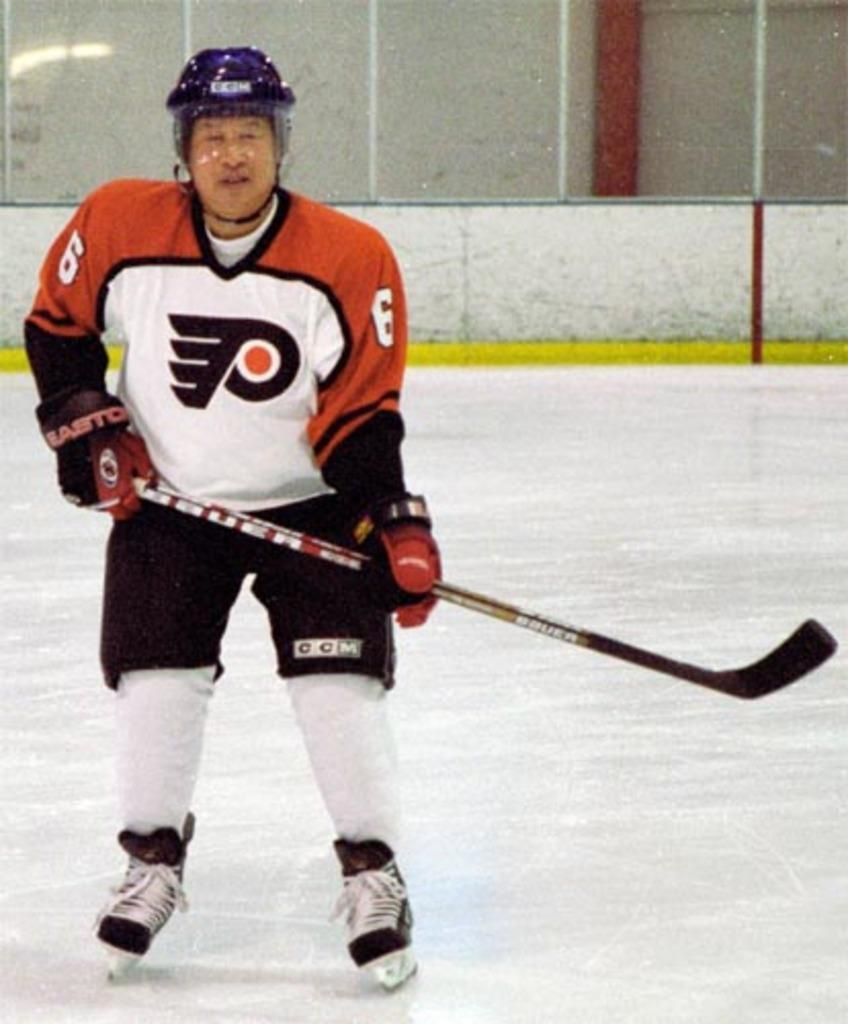Who or what is present in the image? There is a person in the image. What is the person wearing? The person is wearing a dress with white, orange, and black colors. What is the person holding in the image? The person is holding a hockey stick. What can be seen in the background of the image? There is a white-colored wall in the background of the image. What type of bells can be heard ringing in the image? There are no bells present in the image, and therefore no sound can be heard. 